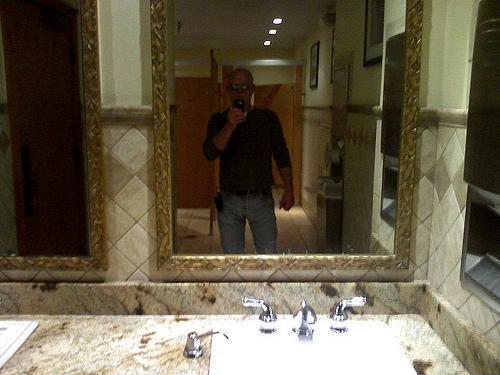How many lights are in the ceiling?
Give a very brief answer. 3. How many pictures are seen?
Give a very brief answer. 2. 